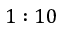<formula> <loc_0><loc_0><loc_500><loc_500>1 \colon 1 0</formula> 